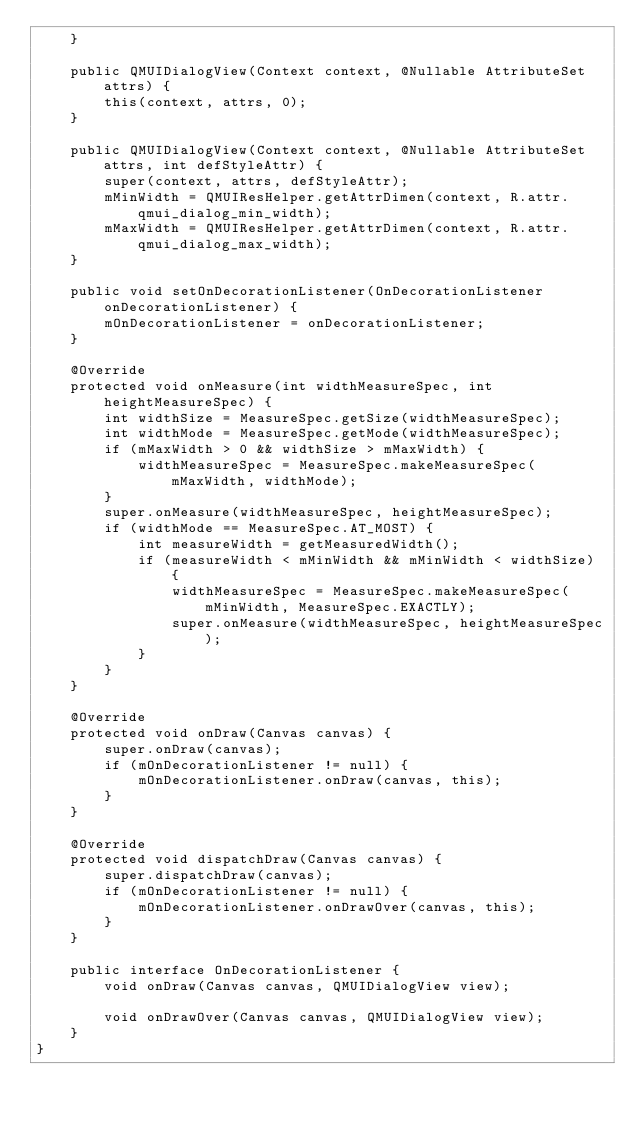<code> <loc_0><loc_0><loc_500><loc_500><_Java_>    }

    public QMUIDialogView(Context context, @Nullable AttributeSet attrs) {
        this(context, attrs, 0);
    }

    public QMUIDialogView(Context context, @Nullable AttributeSet attrs, int defStyleAttr) {
        super(context, attrs, defStyleAttr);
        mMinWidth = QMUIResHelper.getAttrDimen(context, R.attr.qmui_dialog_min_width);
        mMaxWidth = QMUIResHelper.getAttrDimen(context, R.attr.qmui_dialog_max_width);
    }

    public void setOnDecorationListener(OnDecorationListener onDecorationListener) {
        mOnDecorationListener = onDecorationListener;
    }

    @Override
    protected void onMeasure(int widthMeasureSpec, int heightMeasureSpec) {
        int widthSize = MeasureSpec.getSize(widthMeasureSpec);
        int widthMode = MeasureSpec.getMode(widthMeasureSpec);
        if (mMaxWidth > 0 && widthSize > mMaxWidth) {
            widthMeasureSpec = MeasureSpec.makeMeasureSpec(mMaxWidth, widthMode);
        }
        super.onMeasure(widthMeasureSpec, heightMeasureSpec);
        if (widthMode == MeasureSpec.AT_MOST) {
            int measureWidth = getMeasuredWidth();
            if (measureWidth < mMinWidth && mMinWidth < widthSize) {
                widthMeasureSpec = MeasureSpec.makeMeasureSpec(mMinWidth, MeasureSpec.EXACTLY);
                super.onMeasure(widthMeasureSpec, heightMeasureSpec);
            }
        }
    }

    @Override
    protected void onDraw(Canvas canvas) {
        super.onDraw(canvas);
        if (mOnDecorationListener != null) {
            mOnDecorationListener.onDraw(canvas, this);
        }
    }

    @Override
    protected void dispatchDraw(Canvas canvas) {
        super.dispatchDraw(canvas);
        if (mOnDecorationListener != null) {
            mOnDecorationListener.onDrawOver(canvas, this);
        }
    }

    public interface OnDecorationListener {
        void onDraw(Canvas canvas, QMUIDialogView view);

        void onDrawOver(Canvas canvas, QMUIDialogView view);
    }
}
</code> 